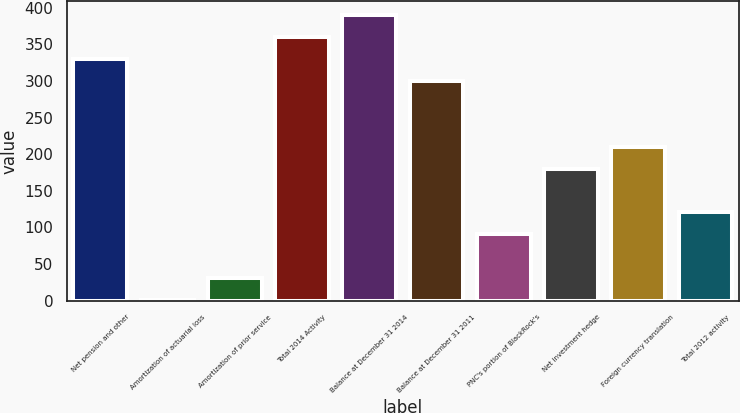<chart> <loc_0><loc_0><loc_500><loc_500><bar_chart><fcel>Net pension and other<fcel>Amortization of actuarial loss<fcel>Amortization of prior service<fcel>Total 2014 Activity<fcel>Balance at December 31 2014<fcel>Balance at December 31 2011<fcel>PNC's portion of BlackRock's<fcel>Net investment hedge<fcel>Foreign currency translation<fcel>Total 2012 activity<nl><fcel>329.9<fcel>1<fcel>30.9<fcel>359.8<fcel>389.7<fcel>300<fcel>90.7<fcel>180.4<fcel>210.3<fcel>120.6<nl></chart> 